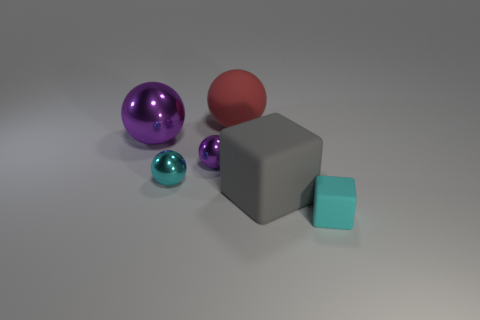What number of cylinders are either large objects or small metal objects?
Keep it short and to the point. 0. How many rubber things are in front of the cyan shiny object and left of the tiny cyan cube?
Provide a short and direct response. 1. Are there an equal number of large objects that are in front of the big gray rubber cube and tiny cyan matte things right of the small cyan rubber cube?
Your response must be concise. Yes. Does the tiny metal object that is behind the cyan shiny sphere have the same shape as the red thing?
Offer a terse response. Yes. The large object that is in front of the cyan object that is to the left of the object behind the large purple thing is what shape?
Provide a short and direct response. Cube. There is a small metallic object that is the same color as the big shiny thing; what is its shape?
Your answer should be very brief. Sphere. What material is the tiny thing that is in front of the tiny purple shiny ball and on the left side of the cyan rubber block?
Your answer should be very brief. Metal. Are there fewer blue metal objects than gray rubber blocks?
Make the answer very short. Yes. There is a large gray matte thing; does it have the same shape as the small cyan thing on the right side of the rubber sphere?
Your answer should be compact. Yes. Does the cyan thing that is in front of the gray rubber block have the same size as the large purple ball?
Provide a short and direct response. No. 